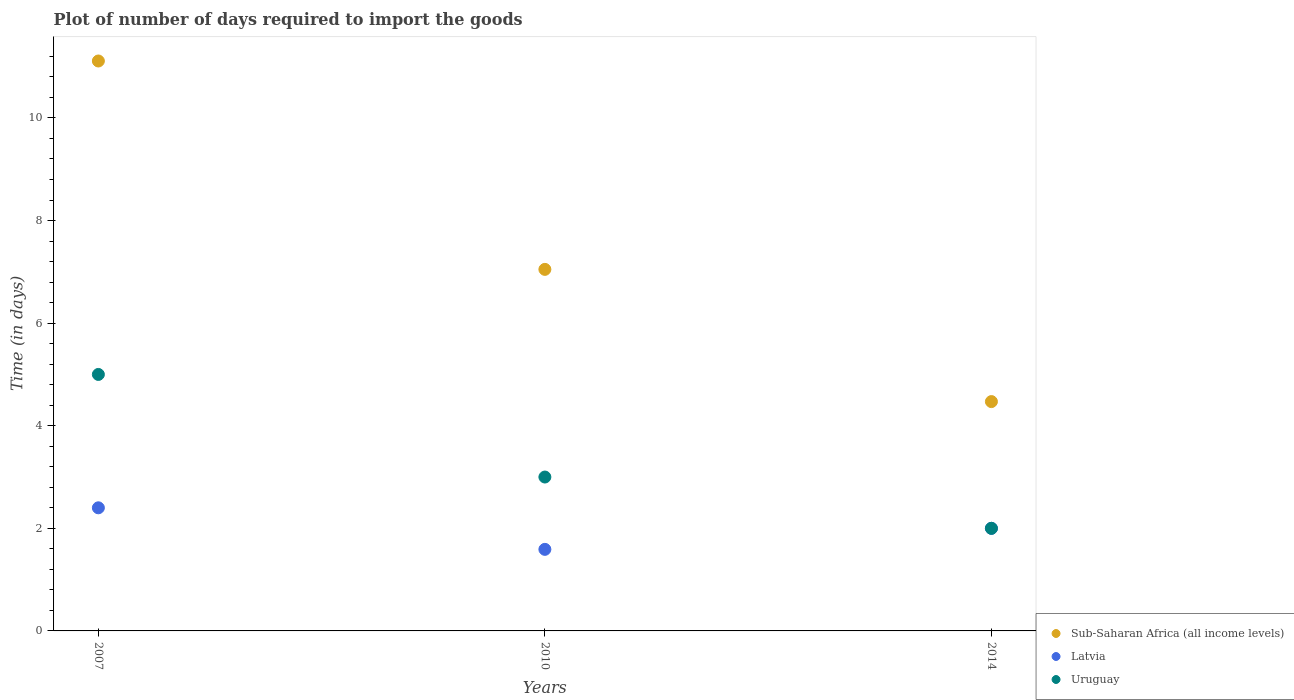How many different coloured dotlines are there?
Offer a very short reply. 3. What is the time required to import goods in Sub-Saharan Africa (all income levels) in 2014?
Provide a short and direct response. 4.47. Across all years, what is the maximum time required to import goods in Uruguay?
Give a very brief answer. 5. Across all years, what is the minimum time required to import goods in Uruguay?
Provide a succinct answer. 2. In which year was the time required to import goods in Sub-Saharan Africa (all income levels) maximum?
Your response must be concise. 2007. What is the total time required to import goods in Sub-Saharan Africa (all income levels) in the graph?
Make the answer very short. 22.63. What is the difference between the time required to import goods in Uruguay in 2007 and that in 2014?
Provide a succinct answer. 3. What is the difference between the time required to import goods in Sub-Saharan Africa (all income levels) in 2014 and the time required to import goods in Uruguay in 2010?
Offer a terse response. 1.47. What is the average time required to import goods in Uruguay per year?
Ensure brevity in your answer.  3.33. In the year 2014, what is the difference between the time required to import goods in Sub-Saharan Africa (all income levels) and time required to import goods in Uruguay?
Offer a terse response. 2.47. In how many years, is the time required to import goods in Uruguay greater than 6 days?
Keep it short and to the point. 0. What is the ratio of the time required to import goods in Sub-Saharan Africa (all income levels) in 2007 to that in 2014?
Ensure brevity in your answer.  2.49. What is the difference between the highest and the second highest time required to import goods in Sub-Saharan Africa (all income levels)?
Your response must be concise. 4.06. What is the difference between the highest and the lowest time required to import goods in Sub-Saharan Africa (all income levels)?
Your response must be concise. 6.64. In how many years, is the time required to import goods in Uruguay greater than the average time required to import goods in Uruguay taken over all years?
Offer a very short reply. 1. Is the sum of the time required to import goods in Uruguay in 2007 and 2014 greater than the maximum time required to import goods in Sub-Saharan Africa (all income levels) across all years?
Give a very brief answer. No. Does the time required to import goods in Sub-Saharan Africa (all income levels) monotonically increase over the years?
Ensure brevity in your answer.  No. Is the time required to import goods in Latvia strictly less than the time required to import goods in Sub-Saharan Africa (all income levels) over the years?
Make the answer very short. Yes. How many dotlines are there?
Offer a terse response. 3. What is the difference between two consecutive major ticks on the Y-axis?
Keep it short and to the point. 2. Are the values on the major ticks of Y-axis written in scientific E-notation?
Make the answer very short. No. Does the graph contain grids?
Provide a succinct answer. No. How are the legend labels stacked?
Keep it short and to the point. Vertical. What is the title of the graph?
Keep it short and to the point. Plot of number of days required to import the goods. What is the label or title of the X-axis?
Offer a very short reply. Years. What is the label or title of the Y-axis?
Make the answer very short. Time (in days). What is the Time (in days) of Sub-Saharan Africa (all income levels) in 2007?
Provide a succinct answer. 11.11. What is the Time (in days) in Latvia in 2007?
Give a very brief answer. 2.4. What is the Time (in days) in Sub-Saharan Africa (all income levels) in 2010?
Your response must be concise. 7.05. What is the Time (in days) in Latvia in 2010?
Make the answer very short. 1.59. What is the Time (in days) of Sub-Saharan Africa (all income levels) in 2014?
Your response must be concise. 4.47. What is the Time (in days) of Latvia in 2014?
Make the answer very short. 2. What is the Time (in days) of Uruguay in 2014?
Your response must be concise. 2. Across all years, what is the maximum Time (in days) in Sub-Saharan Africa (all income levels)?
Keep it short and to the point. 11.11. Across all years, what is the maximum Time (in days) of Latvia?
Your response must be concise. 2.4. Across all years, what is the maximum Time (in days) of Uruguay?
Offer a terse response. 5. Across all years, what is the minimum Time (in days) in Sub-Saharan Africa (all income levels)?
Offer a very short reply. 4.47. Across all years, what is the minimum Time (in days) of Latvia?
Offer a very short reply. 1.59. Across all years, what is the minimum Time (in days) of Uruguay?
Your answer should be compact. 2. What is the total Time (in days) in Sub-Saharan Africa (all income levels) in the graph?
Your answer should be very brief. 22.63. What is the total Time (in days) of Latvia in the graph?
Offer a terse response. 5.99. What is the difference between the Time (in days) in Sub-Saharan Africa (all income levels) in 2007 and that in 2010?
Your answer should be very brief. 4.06. What is the difference between the Time (in days) of Latvia in 2007 and that in 2010?
Your response must be concise. 0.81. What is the difference between the Time (in days) of Sub-Saharan Africa (all income levels) in 2007 and that in 2014?
Your answer should be compact. 6.64. What is the difference between the Time (in days) of Latvia in 2007 and that in 2014?
Provide a short and direct response. 0.4. What is the difference between the Time (in days) of Sub-Saharan Africa (all income levels) in 2010 and that in 2014?
Give a very brief answer. 2.58. What is the difference between the Time (in days) in Latvia in 2010 and that in 2014?
Your answer should be compact. -0.41. What is the difference between the Time (in days) of Uruguay in 2010 and that in 2014?
Your answer should be compact. 1. What is the difference between the Time (in days) in Sub-Saharan Africa (all income levels) in 2007 and the Time (in days) in Latvia in 2010?
Offer a terse response. 9.52. What is the difference between the Time (in days) of Sub-Saharan Africa (all income levels) in 2007 and the Time (in days) of Uruguay in 2010?
Offer a very short reply. 8.11. What is the difference between the Time (in days) of Latvia in 2007 and the Time (in days) of Uruguay in 2010?
Your answer should be very brief. -0.6. What is the difference between the Time (in days) in Sub-Saharan Africa (all income levels) in 2007 and the Time (in days) in Latvia in 2014?
Your response must be concise. 9.11. What is the difference between the Time (in days) of Sub-Saharan Africa (all income levels) in 2007 and the Time (in days) of Uruguay in 2014?
Provide a succinct answer. 9.11. What is the difference between the Time (in days) in Latvia in 2007 and the Time (in days) in Uruguay in 2014?
Offer a terse response. 0.4. What is the difference between the Time (in days) in Sub-Saharan Africa (all income levels) in 2010 and the Time (in days) in Latvia in 2014?
Your answer should be very brief. 5.05. What is the difference between the Time (in days) of Sub-Saharan Africa (all income levels) in 2010 and the Time (in days) of Uruguay in 2014?
Offer a very short reply. 5.05. What is the difference between the Time (in days) in Latvia in 2010 and the Time (in days) in Uruguay in 2014?
Your answer should be very brief. -0.41. What is the average Time (in days) of Sub-Saharan Africa (all income levels) per year?
Give a very brief answer. 7.54. What is the average Time (in days) in Latvia per year?
Ensure brevity in your answer.  2. What is the average Time (in days) of Uruguay per year?
Ensure brevity in your answer.  3.33. In the year 2007, what is the difference between the Time (in days) of Sub-Saharan Africa (all income levels) and Time (in days) of Latvia?
Your answer should be compact. 8.71. In the year 2007, what is the difference between the Time (in days) in Sub-Saharan Africa (all income levels) and Time (in days) in Uruguay?
Provide a short and direct response. 6.11. In the year 2010, what is the difference between the Time (in days) in Sub-Saharan Africa (all income levels) and Time (in days) in Latvia?
Provide a short and direct response. 5.46. In the year 2010, what is the difference between the Time (in days) in Sub-Saharan Africa (all income levels) and Time (in days) in Uruguay?
Provide a short and direct response. 4.05. In the year 2010, what is the difference between the Time (in days) in Latvia and Time (in days) in Uruguay?
Your answer should be very brief. -1.41. In the year 2014, what is the difference between the Time (in days) of Sub-Saharan Africa (all income levels) and Time (in days) of Latvia?
Ensure brevity in your answer.  2.47. In the year 2014, what is the difference between the Time (in days) of Sub-Saharan Africa (all income levels) and Time (in days) of Uruguay?
Give a very brief answer. 2.47. What is the ratio of the Time (in days) in Sub-Saharan Africa (all income levels) in 2007 to that in 2010?
Provide a short and direct response. 1.58. What is the ratio of the Time (in days) of Latvia in 2007 to that in 2010?
Provide a short and direct response. 1.51. What is the ratio of the Time (in days) in Uruguay in 2007 to that in 2010?
Keep it short and to the point. 1.67. What is the ratio of the Time (in days) of Sub-Saharan Africa (all income levels) in 2007 to that in 2014?
Give a very brief answer. 2.49. What is the ratio of the Time (in days) of Uruguay in 2007 to that in 2014?
Your answer should be very brief. 2.5. What is the ratio of the Time (in days) of Sub-Saharan Africa (all income levels) in 2010 to that in 2014?
Your answer should be very brief. 1.58. What is the ratio of the Time (in days) in Latvia in 2010 to that in 2014?
Ensure brevity in your answer.  0.8. What is the difference between the highest and the second highest Time (in days) in Sub-Saharan Africa (all income levels)?
Offer a terse response. 4.06. What is the difference between the highest and the second highest Time (in days) of Latvia?
Give a very brief answer. 0.4. What is the difference between the highest and the second highest Time (in days) of Uruguay?
Offer a very short reply. 2. What is the difference between the highest and the lowest Time (in days) in Sub-Saharan Africa (all income levels)?
Provide a succinct answer. 6.64. What is the difference between the highest and the lowest Time (in days) in Latvia?
Provide a succinct answer. 0.81. 